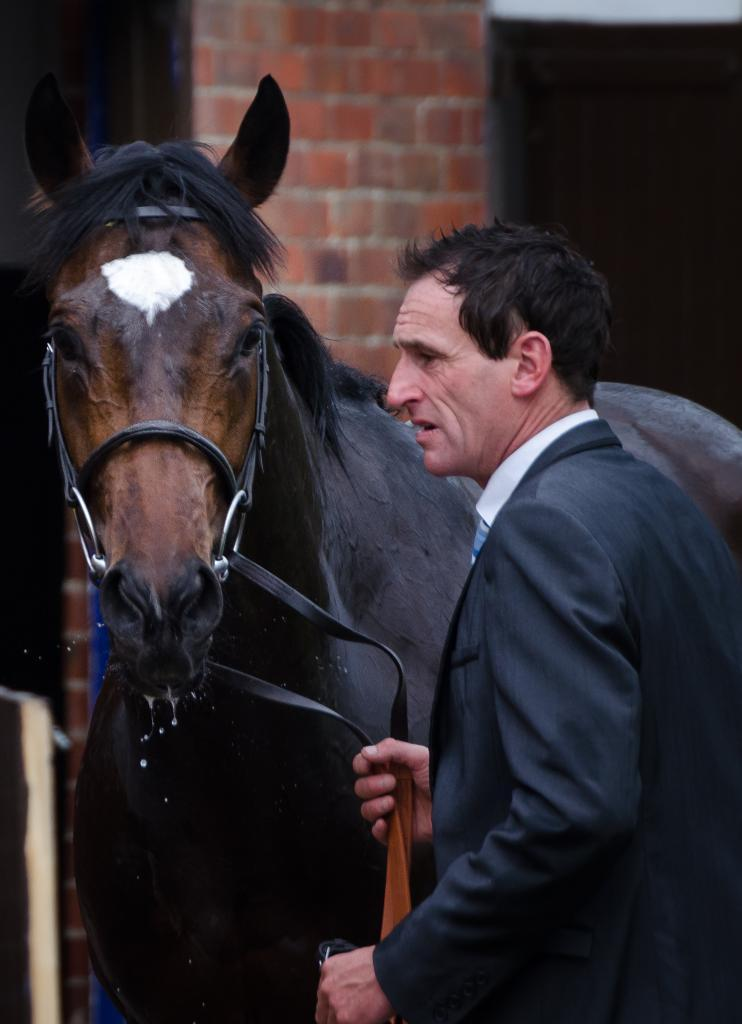Who is the main subject in the image? There is a man in the image. What is the man holding in the image? The man is holding a horse. How is the horse connected to the man? The horse is connected to the man with a string. What account number does the man provide to the representative in the image? There is no mention of an account number, representative, or decision in the image. The image only shows a man holding a horse connected to him with a string. 